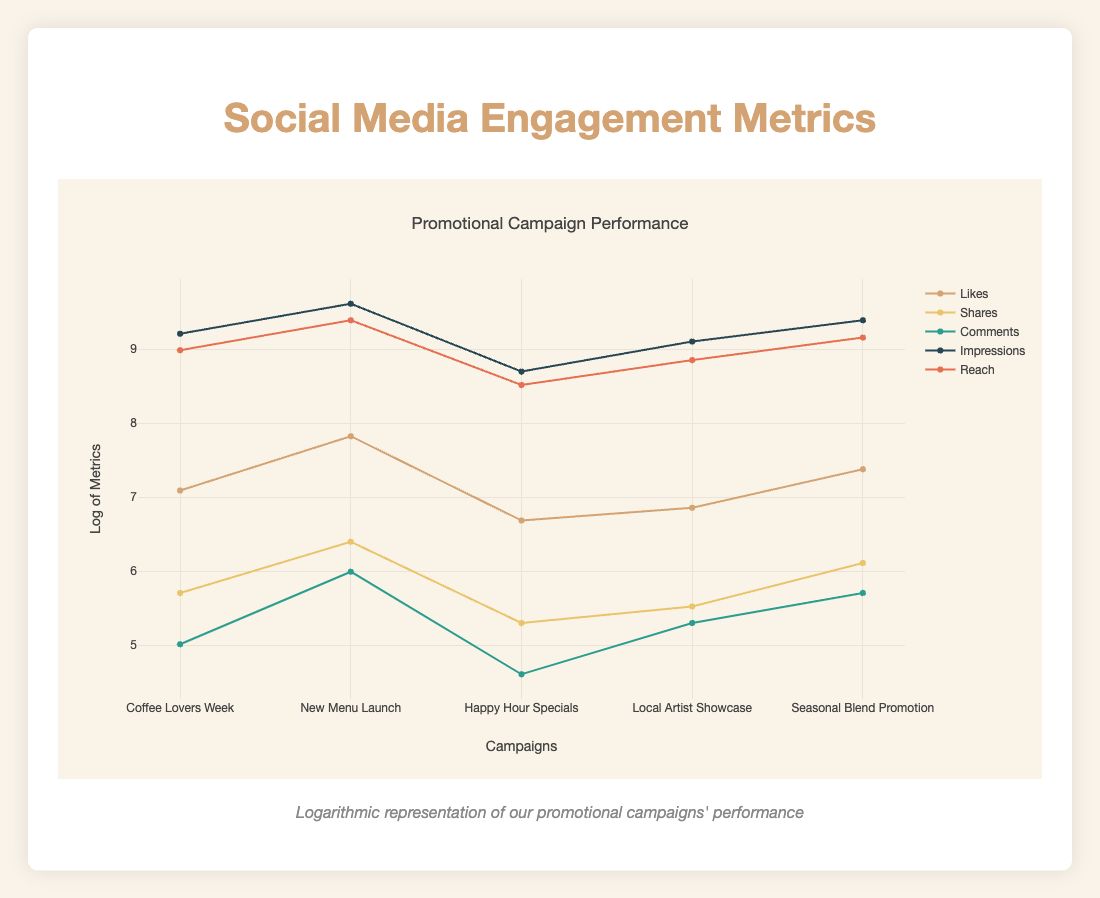What is the highest number of likes received in a campaign? The campaign with the highest number of likes is "New Menu Launch," which received 2500 likes.
Answer: 2500 Which campaign had the least number of shares? The campaign with the least number of shares is "Happy Hour Specials," with only 200 shares.
Answer: 200 Calculate the average number of comments across all campaigns. Summing the comments gives us (150 + 400 + 100 + 200 + 300) = 1150. There are 5 campaigns, so the average is 1150/5 = 230.
Answer: 230 Did the "Seasonal Blend Promotion" receive more likes than "Local Artist Showcase"? "Seasonal Blend Promotion" received 1600 likes, while "Local Artist Showcase" received 950 likes. Therefore, the statement is true.
Answer: Yes What is the total number of impressions from all campaigns? The total number of impressions is calculated by adding (10000 + 15000 + 6000 + 9000 + 12000) = 60000.
Answer: 60000 Which campaign had the highest reach? The "New Menu Launch" campaign had the highest reach, with 12000.
Answer: 12000 If we combine the likes and shares from the "Coffee Lovers Week" and "Seasonal Blend Promotion," what is the total? "Coffee Lovers Week" has 1200 likes and 300 shares, while "Seasonal Blend Promotion" has 1600 likes and 450 shares. Therefore, the total is (1200 + 300 + 1600 + 450) = 3550.
Answer: 3550 How many comments did the campaigns collect in total? Adding all comments together gives (150 + 400 + 100 + 200 + 300) = 1150 comments in total across the campaigns.
Answer: 1150 Was the reach of the "Happy Hour Specials" lower than that of the "Coffee Lovers Week"? The "Happy Hour Specials" had a reach of 5000, while the "Coffee Lovers Week" had a reach of 8000. This statement is true.
Answer: Yes 